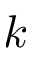Convert formula to latex. <formula><loc_0><loc_0><loc_500><loc_500>k</formula> 